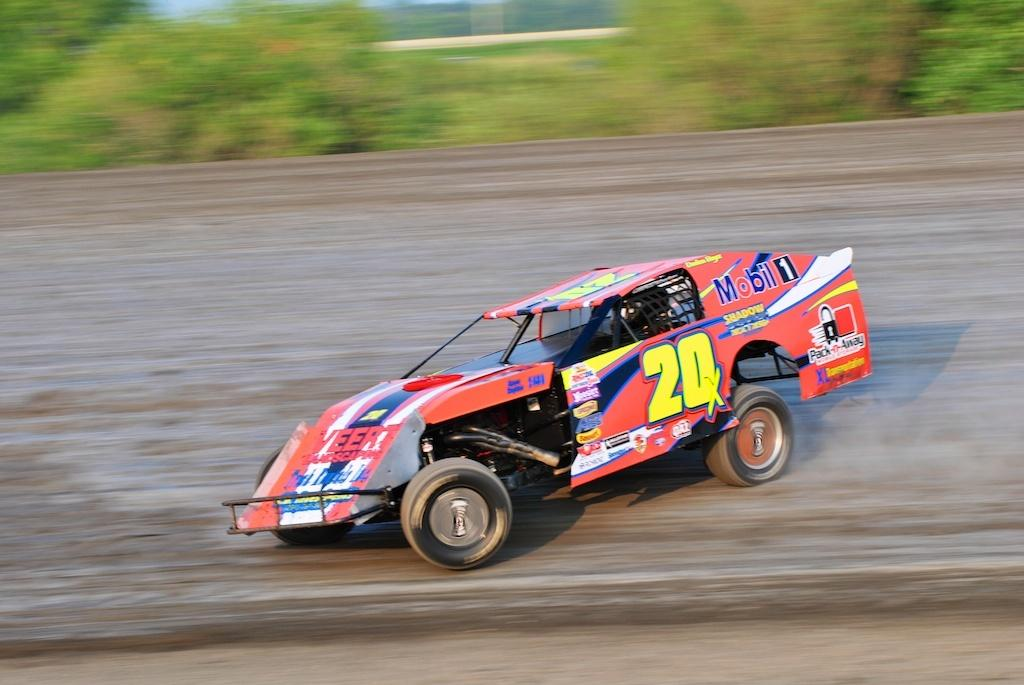What is the main subject of the image? There is a car in the image. What colors can be seen on the car? The car is orange, blue, yellow, and white in color. Where is the car located in the image? The car is on the road. Can you describe the background of the image? There is a blurry background in the image, with trees and other objects visible. What is the reason for the car's sudden stop in the image? There is no indication of a sudden stop in the image, and therefore no reason can be determined. How many things can be seen in the background of the image? It is not possible to count the exact number of objects visible in the background, but trees and other objects are mentioned. 